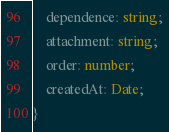<code> <loc_0><loc_0><loc_500><loc_500><_TypeScript_>    dependence: string;
    attachment: string;
    order: number;
    createdAt: Date;
}</code> 